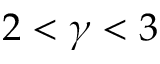<formula> <loc_0><loc_0><loc_500><loc_500>2 < \gamma < 3</formula> 